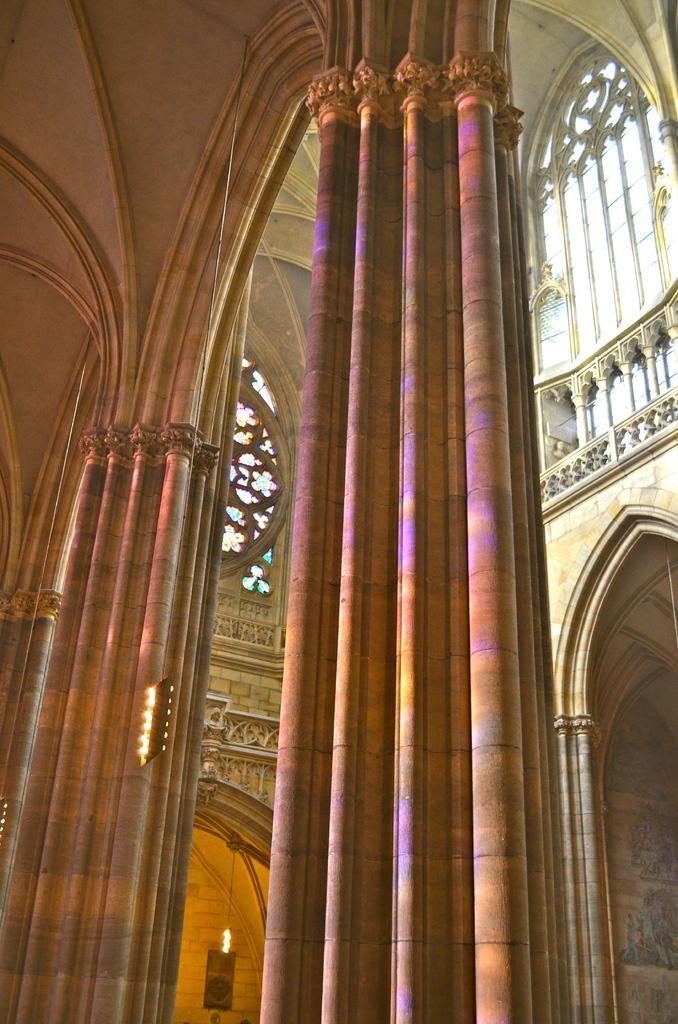Please provide a concise description of this image. In this image there is a building truncated, there are pillars, there is fire, there is wall, there is a painting on the wall. 